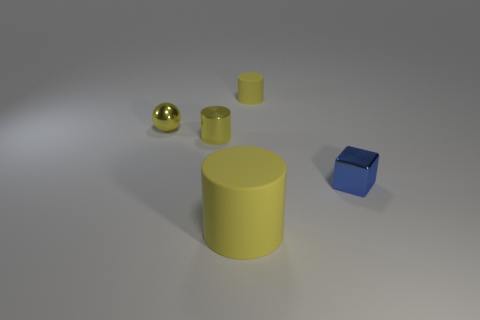How many yellow cylinders must be subtracted to get 1 yellow cylinders? 2 Add 3 small yellow rubber spheres. How many objects exist? 8 Subtract all blocks. How many objects are left? 4 Subtract 0 blue cylinders. How many objects are left? 5 Subtract all small yellow balls. Subtract all big blue rubber spheres. How many objects are left? 4 Add 5 big matte objects. How many big matte objects are left? 6 Add 4 large objects. How many large objects exist? 5 